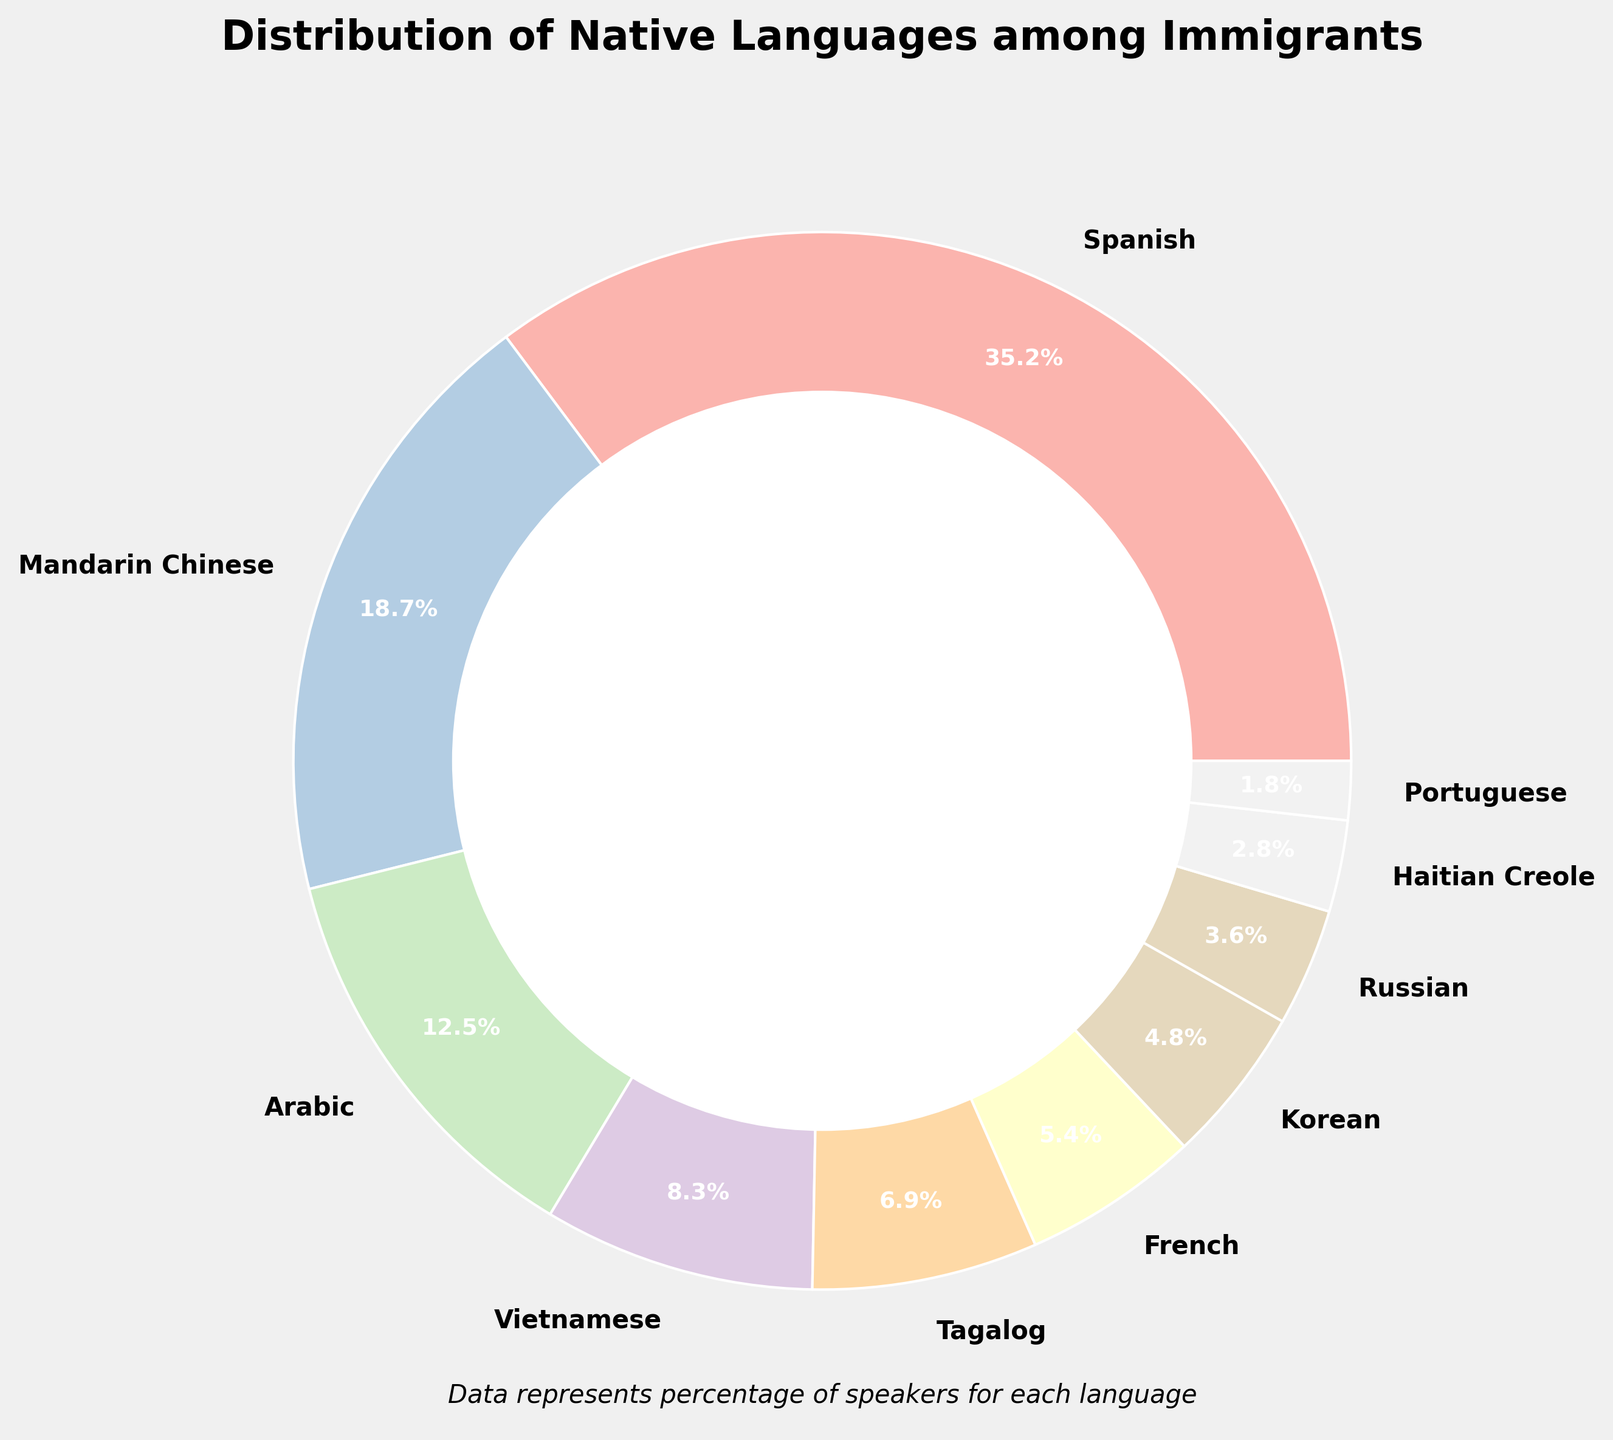what's the most common native language among the immigrants? The largest segment of the pie chart will represent the native language with the highest percentage. The segment labeled "Spanish" occupies the largest area with 35.2%.
Answer: Spanish which native language has nearly half the percentage of Arabic? First find the percentage for Arabic, which is 12.5%. Half of 12.5% is 6.25%. The segment closest to 6.25% is "Tagalog" with 6.9%.
Answer: Tagalog compare the percentages of Spanish and Mandarin Chinese speakers together to the total combined percentage of Arabic, Vietnamese, and Tagalog. Which is higher? Combine the percentages of Spanish (35.2%) and Mandarin Chinese (18.7%) to get 53.9%. Then add the percentages of Arabic (12.5%), Vietnamese (8.3%), and Tagalog (6.9%) to get 27.7%. 53.9% is higher than 27.7%.
Answer: Spanish and Mandarin Chinese speakers how much larger is the percentage of Spanish speakers compared to Korean speakers? The percentage of Spanish speakers is 35.2%. and for Korean speakers is 4.8%. The difference is 35.2% - 4.8% = 30.4%.
Answer: 30.4% what is the slightest difference in percentage between any two languages shown in the pie chart, and which languages are they? Inspect the percentages and find the smallest difference. The slightest difference is between French (5.4%) and Korean (4.8%). The difference is 5.4% - 4.8% = 0.6%.
Answer: French and Korean, 0.6% total percentage of immigrants speaking Russian or Portuguese? Sum the percentages of Russian speakers (3.6%) and Portuguese speakers (1.8%) to get 3.6% + 1.8% = 5.4%.
Answer: 5.4% which language segment is visually smallest in the pie chart and what is its percentage? The smallest segment would represent the smallest percentage. The segment labeled "Portuguese" is the smallest with 1.8%.
Answer: Portuguese, 1.8% how does the percentage of Haitian Creole speakers compare to that of Vietnamese speakers? The percentage for Haitian Creole is 2.8% and for Vietnamese is 8.3%. Thus, Vietnamese speakers make up a larger percentage than Haitian Creole speakers.
Answer: Vietnamese speakers have a higher percentage than Haitian Creole speakers 